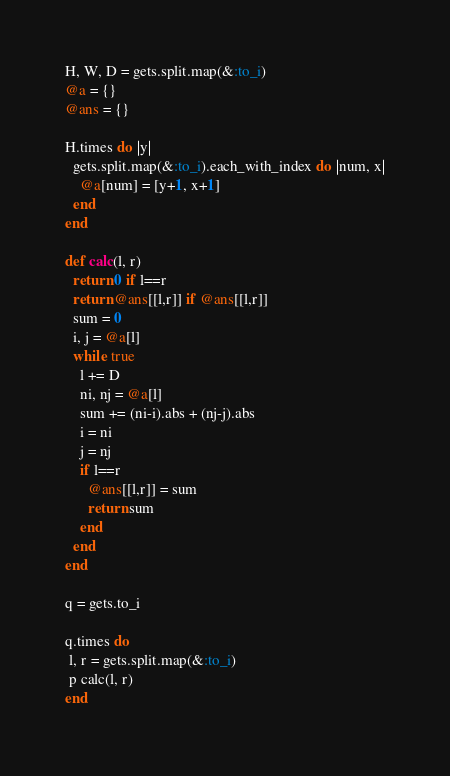<code> <loc_0><loc_0><loc_500><loc_500><_Ruby_>H, W, D = gets.split.map(&:to_i)
@a = {}
@ans = {}

H.times do |y|
  gets.split.map(&:to_i).each_with_index do |num, x|
    @a[num] = [y+1, x+1]
  end
end

def calc(l, r)
  return 0 if l==r
  return @ans[[l,r]] if @ans[[l,r]]
  sum = 0
  i, j = @a[l]
  while true
    l += D
    ni, nj = @a[l]
    sum += (ni-i).abs + (nj-j).abs 
    i = ni
    j = nj
    if l==r
      @ans[[l,r]] = sum
      return sum
    end
  end
end

q = gets.to_i

q.times do
 l, r = gets.split.map(&:to_i)
 p calc(l, r)
end
</code> 